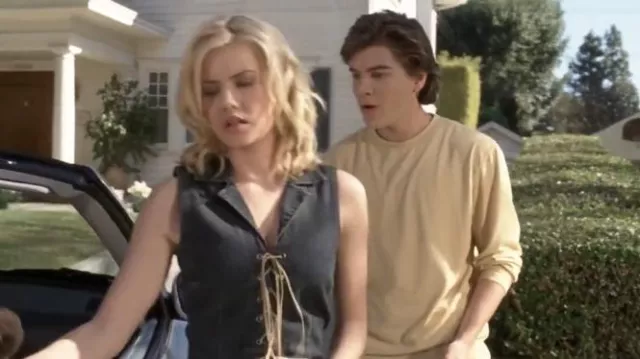What is this photo about? In this image, we observe a tense moment between two characters. The actress in the foreground, identifiable by her blonde hair and expressive eyes, is wearing a vibrant blue sleeveless top with a lace-up neckline. Her body language, which includes walking away from a car with her back slightly turned to a young man, suggests she is upset or angry. The young man, dressed in a beige sweater and standing by the car, appears concerned and unsure about whether to follow or let her go. The car and the surrounding suburban setting add context to their interaction, implying they might be in the middle of a significant journey or decision point. 